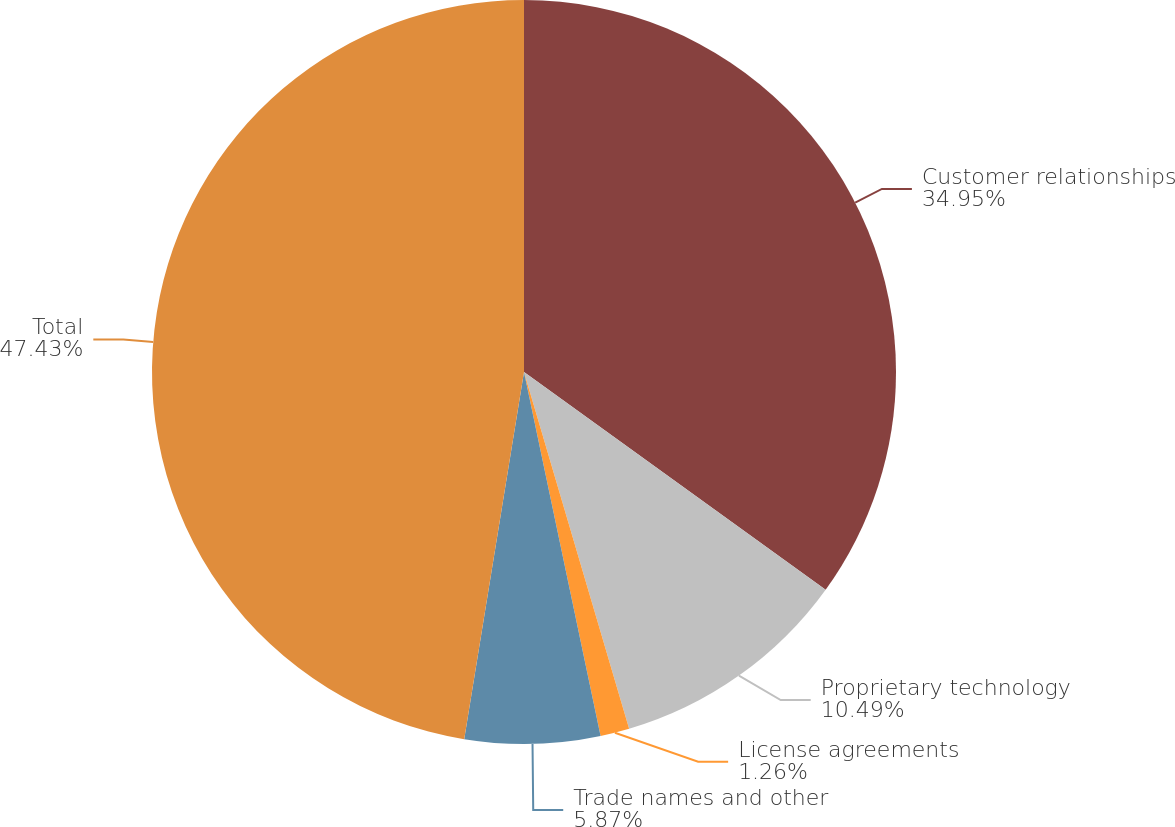Convert chart. <chart><loc_0><loc_0><loc_500><loc_500><pie_chart><fcel>Customer relationships<fcel>Proprietary technology<fcel>License agreements<fcel>Trade names and other<fcel>Total<nl><fcel>34.95%<fcel>10.49%<fcel>1.26%<fcel>5.87%<fcel>47.43%<nl></chart> 